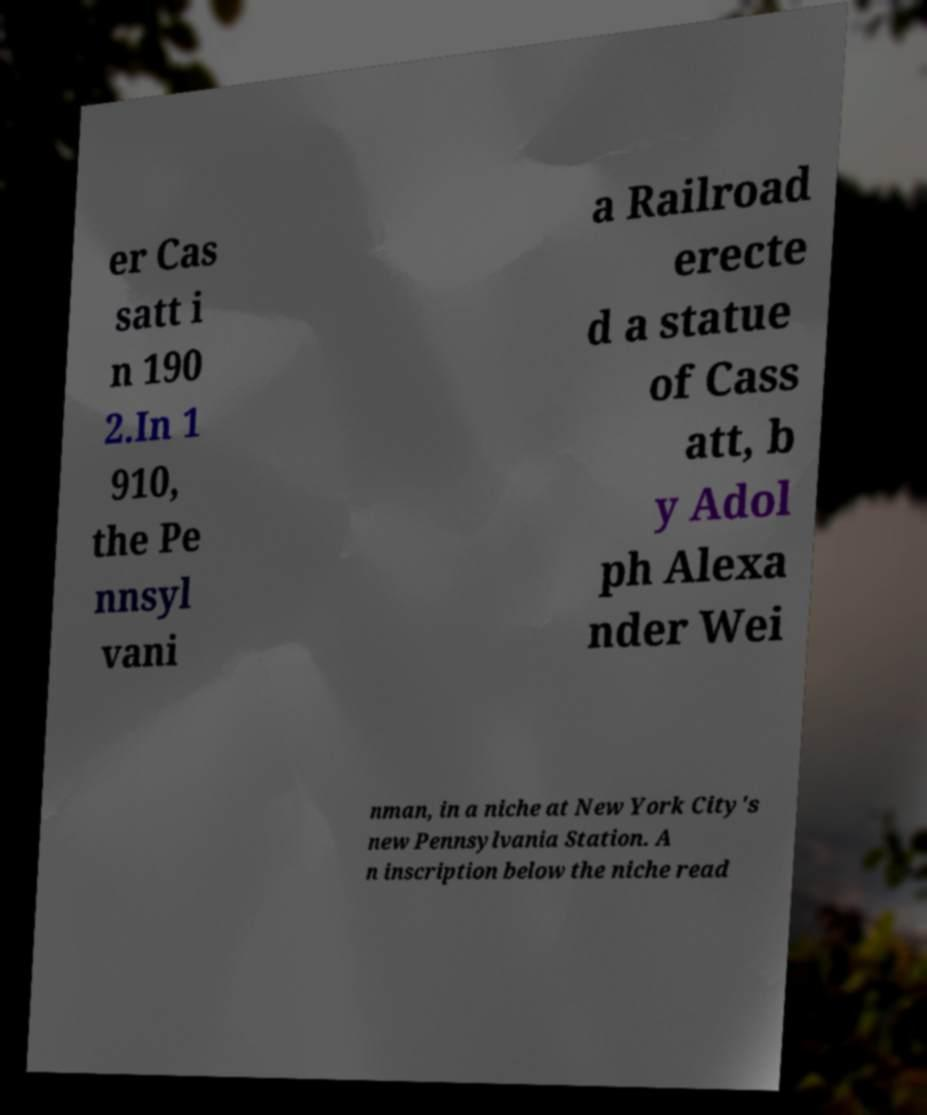Please identify and transcribe the text found in this image. er Cas satt i n 190 2.In 1 910, the Pe nnsyl vani a Railroad erecte d a statue of Cass att, b y Adol ph Alexa nder Wei nman, in a niche at New York City's new Pennsylvania Station. A n inscription below the niche read 